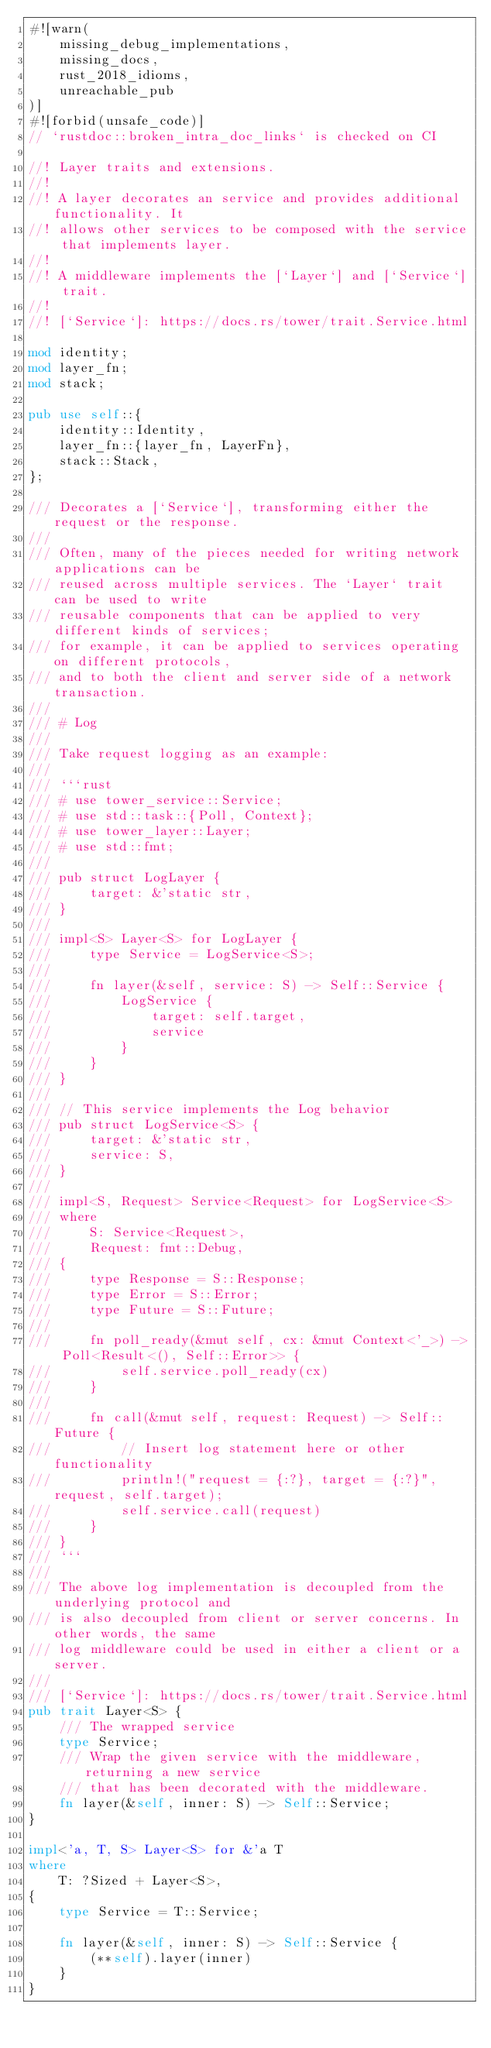<code> <loc_0><loc_0><loc_500><loc_500><_Rust_>#![warn(
    missing_debug_implementations,
    missing_docs,
    rust_2018_idioms,
    unreachable_pub
)]
#![forbid(unsafe_code)]
// `rustdoc::broken_intra_doc_links` is checked on CI

//! Layer traits and extensions.
//!
//! A layer decorates an service and provides additional functionality. It
//! allows other services to be composed with the service that implements layer.
//!
//! A middleware implements the [`Layer`] and [`Service`] trait.
//!
//! [`Service`]: https://docs.rs/tower/trait.Service.html

mod identity;
mod layer_fn;
mod stack;

pub use self::{
    identity::Identity,
    layer_fn::{layer_fn, LayerFn},
    stack::Stack,
};

/// Decorates a [`Service`], transforming either the request or the response.
///
/// Often, many of the pieces needed for writing network applications can be
/// reused across multiple services. The `Layer` trait can be used to write
/// reusable components that can be applied to very different kinds of services;
/// for example, it can be applied to services operating on different protocols,
/// and to both the client and server side of a network transaction.
///
/// # Log
///
/// Take request logging as an example:
///
/// ```rust
/// # use tower_service::Service;
/// # use std::task::{Poll, Context};
/// # use tower_layer::Layer;
/// # use std::fmt;
///
/// pub struct LogLayer {
///     target: &'static str,
/// }
///
/// impl<S> Layer<S> for LogLayer {
///     type Service = LogService<S>;
///
///     fn layer(&self, service: S) -> Self::Service {
///         LogService {
///             target: self.target,
///             service
///         }
///     }
/// }
///
/// // This service implements the Log behavior
/// pub struct LogService<S> {
///     target: &'static str,
///     service: S,
/// }
///
/// impl<S, Request> Service<Request> for LogService<S>
/// where
///     S: Service<Request>,
///     Request: fmt::Debug,
/// {
///     type Response = S::Response;
///     type Error = S::Error;
///     type Future = S::Future;
///
///     fn poll_ready(&mut self, cx: &mut Context<'_>) -> Poll<Result<(), Self::Error>> {
///         self.service.poll_ready(cx)
///     }
///
///     fn call(&mut self, request: Request) -> Self::Future {
///         // Insert log statement here or other functionality
///         println!("request = {:?}, target = {:?}", request, self.target);
///         self.service.call(request)
///     }
/// }
/// ```
///
/// The above log implementation is decoupled from the underlying protocol and
/// is also decoupled from client or server concerns. In other words, the same
/// log middleware could be used in either a client or a server.
///
/// [`Service`]: https://docs.rs/tower/trait.Service.html
pub trait Layer<S> {
    /// The wrapped service
    type Service;
    /// Wrap the given service with the middleware, returning a new service
    /// that has been decorated with the middleware.
    fn layer(&self, inner: S) -> Self::Service;
}

impl<'a, T, S> Layer<S> for &'a T
where
    T: ?Sized + Layer<S>,
{
    type Service = T::Service;

    fn layer(&self, inner: S) -> Self::Service {
        (**self).layer(inner)
    }
}
</code> 